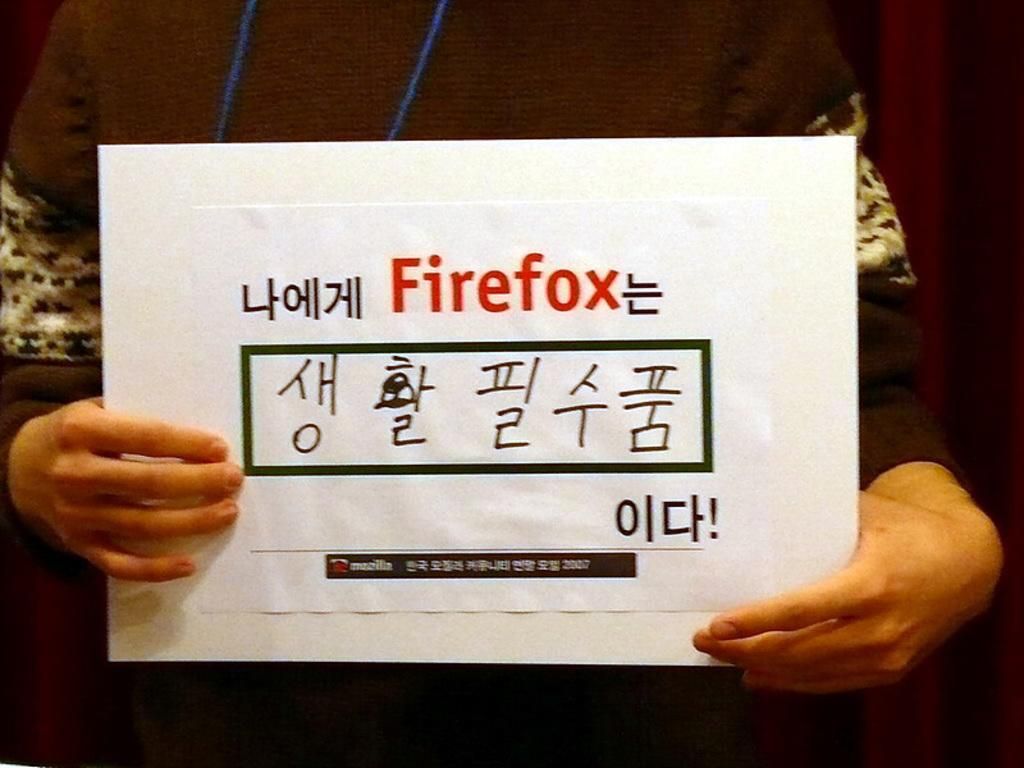Who is present in the image? There is a person in the image. What is the person doing in the image? The person is standing and holding a banner. What is written on the banner? The banner has the word "Firefox" written on it. What type of pets can be seen in the image? There are no pets present in the image. How many wheels are visible in the image? There are no wheels present in the image. 